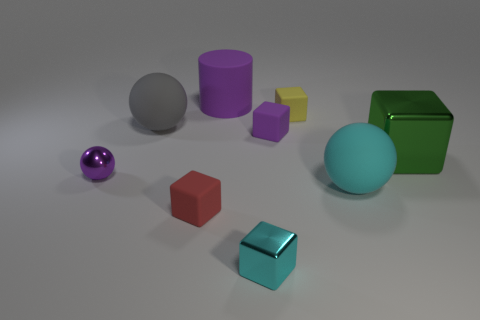There is a big cyan object that is the same material as the tiny yellow cube; what is its shape?
Keep it short and to the point. Sphere. Are there any other things that have the same color as the big cylinder?
Offer a very short reply. Yes. What material is the small purple object that is the same shape as the tiny red rubber object?
Your answer should be compact. Rubber. What number of other objects are the same size as the red block?
Your response must be concise. 4. There is a thing that is the same color as the tiny metallic block; what is its size?
Provide a succinct answer. Large. Does the purple rubber object in front of the large matte cylinder have the same shape as the big green metallic thing?
Provide a short and direct response. Yes. What number of other objects are there of the same shape as the large gray object?
Your response must be concise. 2. What shape is the big thing in front of the green cube?
Your answer should be compact. Sphere. Are there any other purple cylinders that have the same material as the big cylinder?
Your answer should be very brief. No. There is a large rubber thing that is in front of the big green metallic thing; is it the same color as the big metal cube?
Your answer should be very brief. No. 